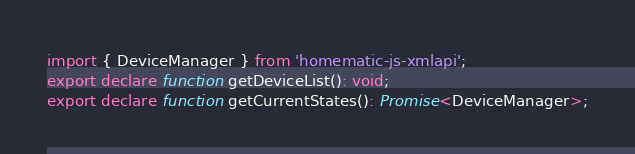<code> <loc_0><loc_0><loc_500><loc_500><_TypeScript_>import { DeviceManager } from 'homematic-js-xmlapi';
export declare function getDeviceList(): void;
export declare function getCurrentStates(): Promise<DeviceManager>;
</code> 